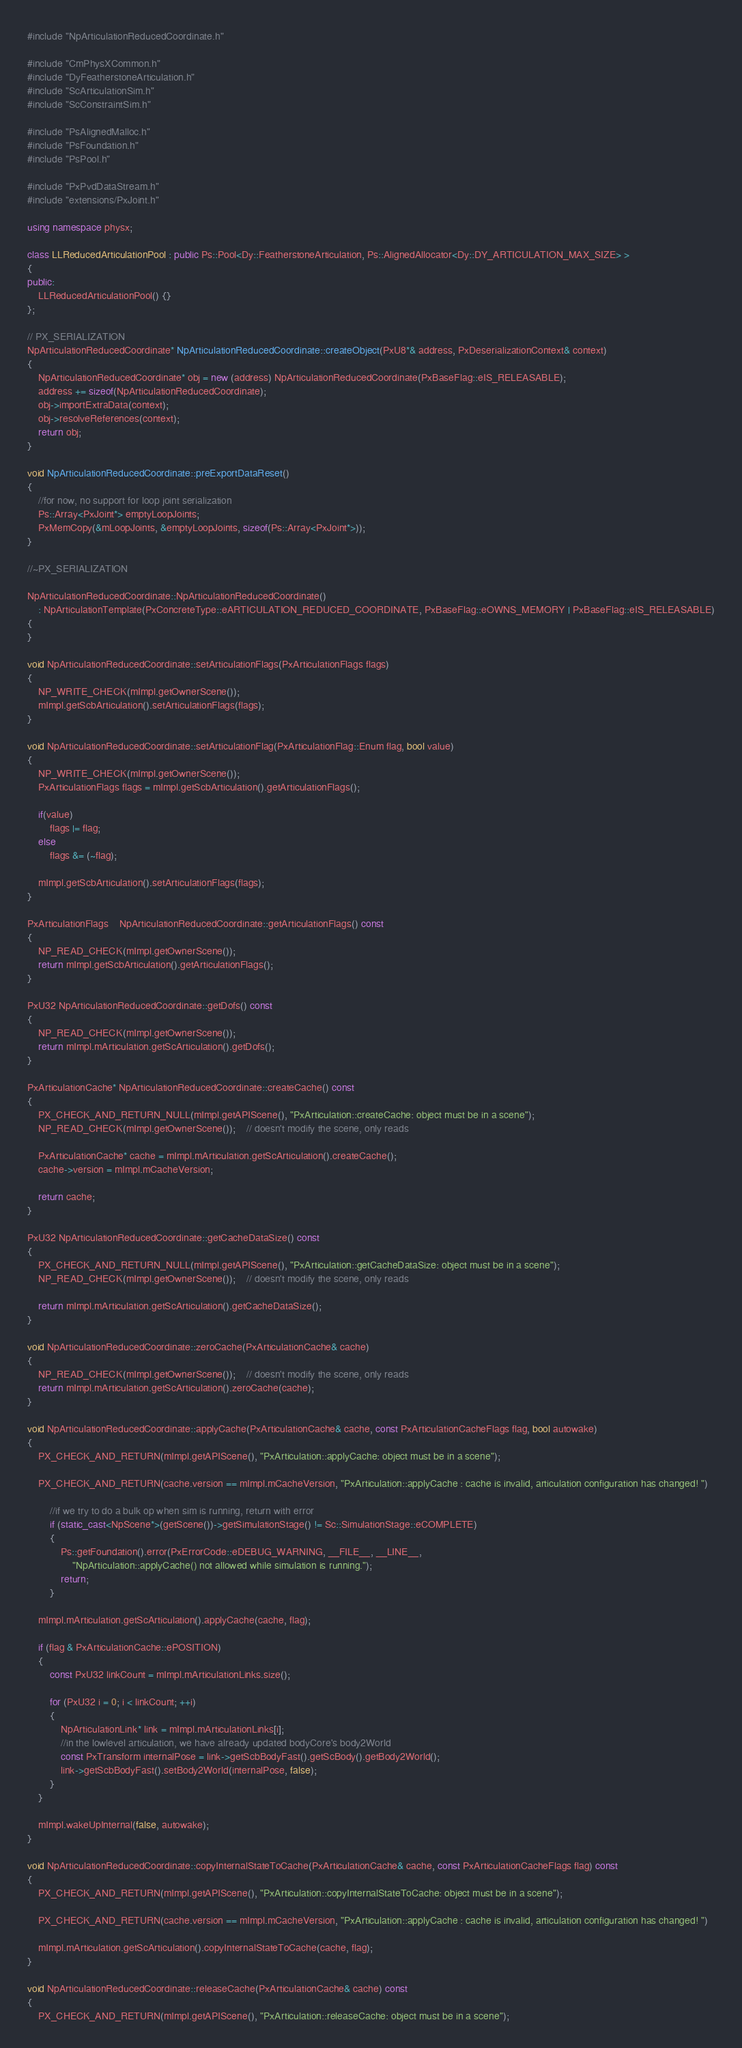<code> <loc_0><loc_0><loc_500><loc_500><_C++_>#include "NpArticulationReducedCoordinate.h"

#include "CmPhysXCommon.h"
#include "DyFeatherstoneArticulation.h"
#include "ScArticulationSim.h"
#include "ScConstraintSim.h"

#include "PsAlignedMalloc.h"
#include "PsFoundation.h"
#include "PsPool.h"

#include "PxPvdDataStream.h"
#include "extensions/PxJoint.h"

using namespace physx;

class LLReducedArticulationPool : public Ps::Pool<Dy::FeatherstoneArticulation, Ps::AlignedAllocator<Dy::DY_ARTICULATION_MAX_SIZE> >
{
public:
	LLReducedArticulationPool() {}
};

// PX_SERIALIZATION
NpArticulationReducedCoordinate* NpArticulationReducedCoordinate::createObject(PxU8*& address, PxDeserializationContext& context)
{
	NpArticulationReducedCoordinate* obj = new (address) NpArticulationReducedCoordinate(PxBaseFlag::eIS_RELEASABLE);
	address += sizeof(NpArticulationReducedCoordinate);
	obj->importExtraData(context);
	obj->resolveReferences(context);
	return obj;
}

void NpArticulationReducedCoordinate::preExportDataReset()
{
	//for now, no support for loop joint serialization
	Ps::Array<PxJoint*> emptyLoopJoints;
	PxMemCopy(&mLoopJoints, &emptyLoopJoints, sizeof(Ps::Array<PxJoint*>));
}

//~PX_SERIALIZATION

NpArticulationReducedCoordinate::NpArticulationReducedCoordinate()
	: NpArticulationTemplate(PxConcreteType::eARTICULATION_REDUCED_COORDINATE, PxBaseFlag::eOWNS_MEMORY | PxBaseFlag::eIS_RELEASABLE)
{
}

void NpArticulationReducedCoordinate::setArticulationFlags(PxArticulationFlags flags)
{
	NP_WRITE_CHECK(mImpl.getOwnerScene());
	mImpl.getScbArticulation().setArticulationFlags(flags);
}

void NpArticulationReducedCoordinate::setArticulationFlag(PxArticulationFlag::Enum flag, bool value)
{
	NP_WRITE_CHECK(mImpl.getOwnerScene());
	PxArticulationFlags flags = mImpl.getScbArticulation().getArticulationFlags();

	if(value)
		flags |= flag;
	else
		flags &= (~flag);

	mImpl.getScbArticulation().setArticulationFlags(flags);
}

PxArticulationFlags	NpArticulationReducedCoordinate::getArticulationFlags() const
{
	NP_READ_CHECK(mImpl.getOwnerScene());
	return mImpl.getScbArticulation().getArticulationFlags();
}

PxU32 NpArticulationReducedCoordinate::getDofs() const
{
	NP_READ_CHECK(mImpl.getOwnerScene());
	return mImpl.mArticulation.getScArticulation().getDofs();
}

PxArticulationCache* NpArticulationReducedCoordinate::createCache() const
{
	PX_CHECK_AND_RETURN_NULL(mImpl.getAPIScene(), "PxArticulation::createCache: object must be in a scene");
	NP_READ_CHECK(mImpl.getOwnerScene());	// doesn't modify the scene, only reads

	PxArticulationCache* cache = mImpl.mArticulation.getScArticulation().createCache();
	cache->version = mImpl.mCacheVersion;

	return cache;
}

PxU32 NpArticulationReducedCoordinate::getCacheDataSize() const
{
	PX_CHECK_AND_RETURN_NULL(mImpl.getAPIScene(), "PxArticulation::getCacheDataSize: object must be in a scene");
	NP_READ_CHECK(mImpl.getOwnerScene());	// doesn't modify the scene, only reads

	return mImpl.mArticulation.getScArticulation().getCacheDataSize();
}

void NpArticulationReducedCoordinate::zeroCache(PxArticulationCache& cache)
{
	NP_READ_CHECK(mImpl.getOwnerScene());	// doesn't modify the scene, only reads
	return mImpl.mArticulation.getScArticulation().zeroCache(cache);
}

void NpArticulationReducedCoordinate::applyCache(PxArticulationCache& cache, const PxArticulationCacheFlags flag, bool autowake)
{
	PX_CHECK_AND_RETURN(mImpl.getAPIScene(), "PxArticulation::applyCache: object must be in a scene");

	PX_CHECK_AND_RETURN(cache.version == mImpl.mCacheVersion, "PxArticulation::applyCache : cache is invalid, articulation configuration has changed! ")

		//if we try to do a bulk op when sim is running, return with error
		if (static_cast<NpScene*>(getScene())->getSimulationStage() != Sc::SimulationStage::eCOMPLETE)
		{
			Ps::getFoundation().error(PxErrorCode::eDEBUG_WARNING, __FILE__, __LINE__,
				"NpArticulation::applyCache() not allowed while simulation is running.");
			return;
		}

	mImpl.mArticulation.getScArticulation().applyCache(cache, flag);

	if (flag & PxArticulationCache::ePOSITION)
	{
		const PxU32 linkCount = mImpl.mArticulationLinks.size();

		for (PxU32 i = 0; i < linkCount; ++i)
		{
			NpArticulationLink* link = mImpl.mArticulationLinks[i];
			//in the lowlevel articulation, we have already updated bodyCore's body2World
			const PxTransform internalPose = link->getScbBodyFast().getScBody().getBody2World();
			link->getScbBodyFast().setBody2World(internalPose, false);
		}
	}

	mImpl.wakeUpInternal(false, autowake);
}

void NpArticulationReducedCoordinate::copyInternalStateToCache(PxArticulationCache& cache, const PxArticulationCacheFlags flag) const
{
	PX_CHECK_AND_RETURN(mImpl.getAPIScene(), "PxArticulation::copyInternalStateToCache: object must be in a scene");

	PX_CHECK_AND_RETURN(cache.version == mImpl.mCacheVersion, "PxArticulation::applyCache : cache is invalid, articulation configuration has changed! ")

	mImpl.mArticulation.getScArticulation().copyInternalStateToCache(cache, flag);
}

void NpArticulationReducedCoordinate::releaseCache(PxArticulationCache& cache) const
{
	PX_CHECK_AND_RETURN(mImpl.getAPIScene(), "PxArticulation::releaseCache: object must be in a scene");</code> 